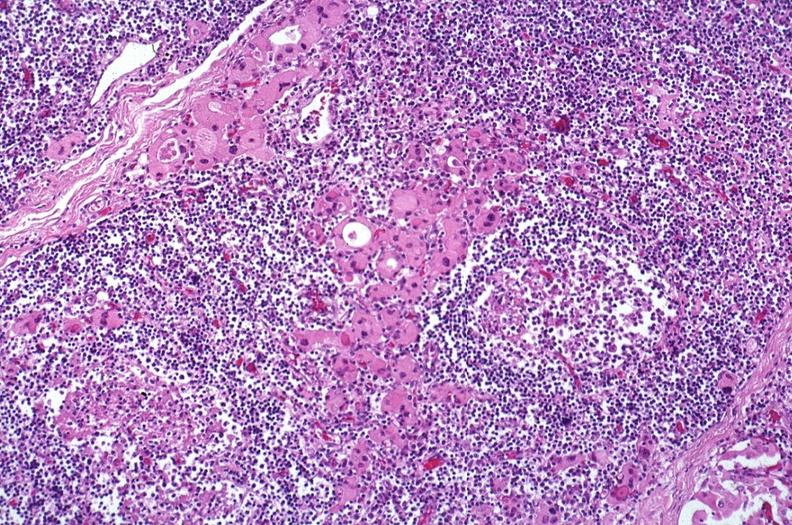what is present?
Answer the question using a single word or phrase. Endocrine 